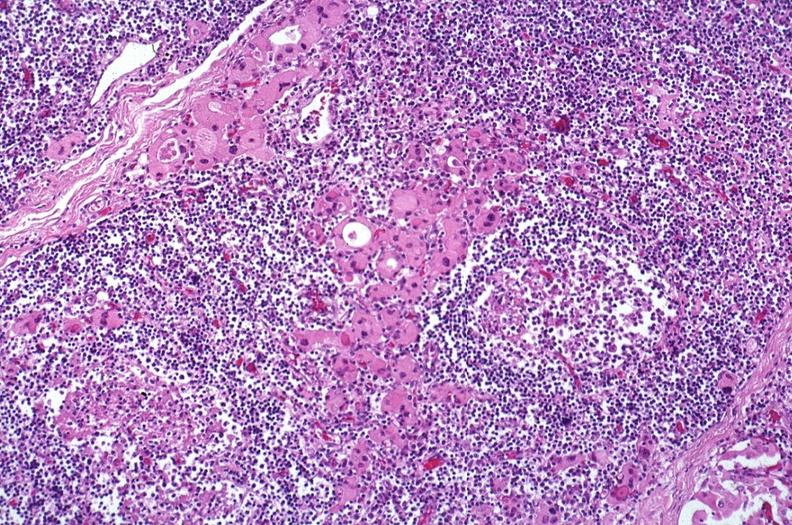what is present?
Answer the question using a single word or phrase. Endocrine 